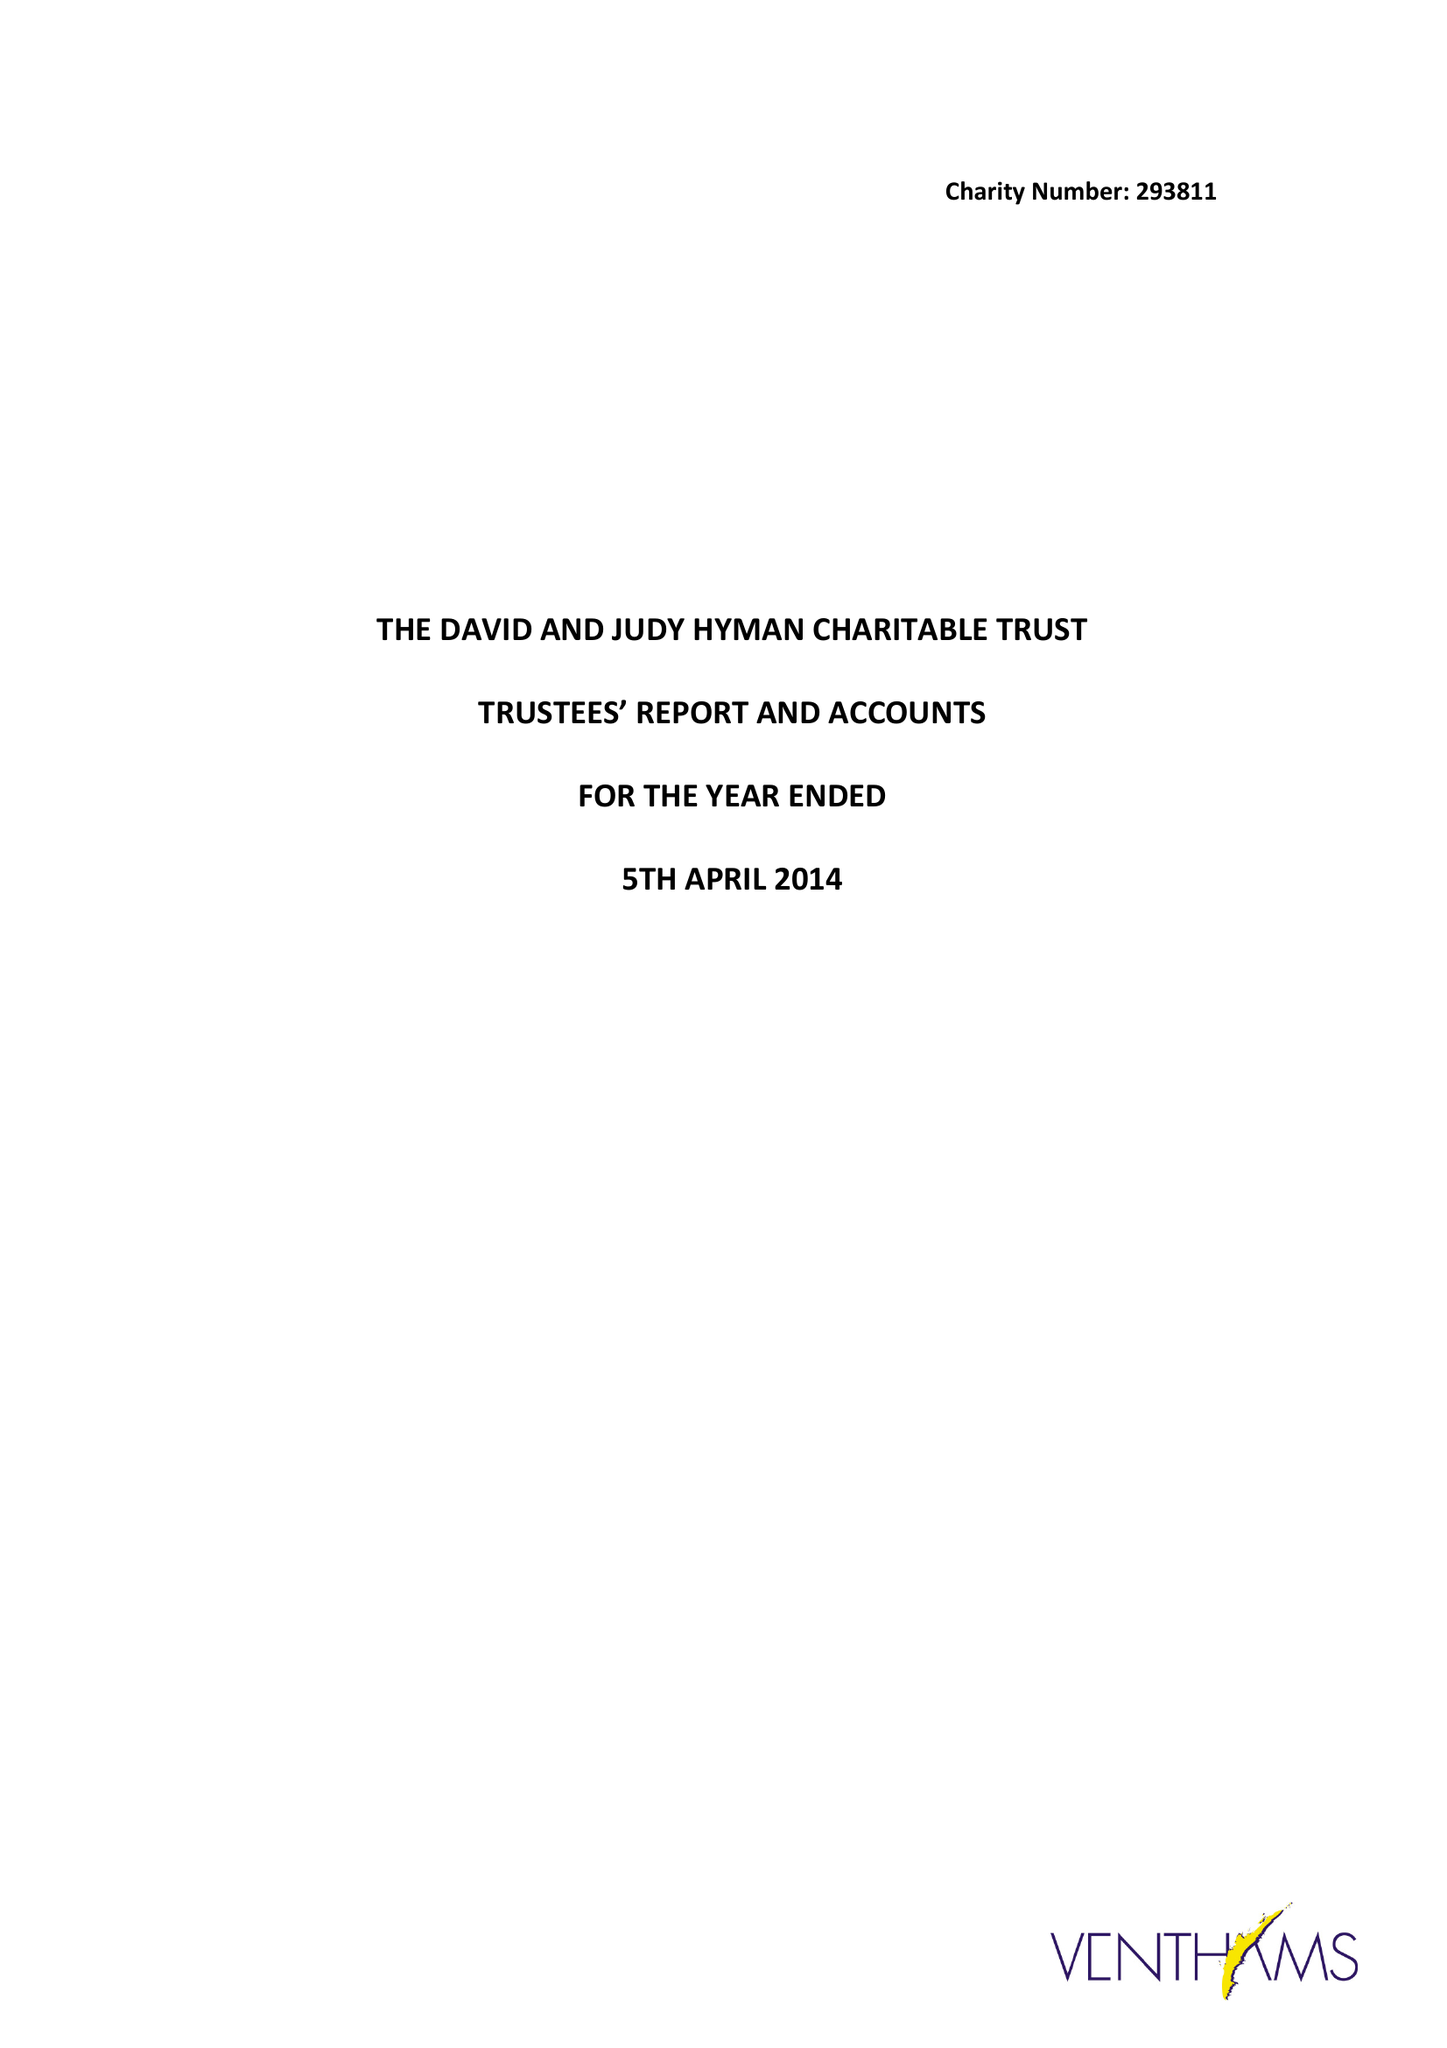What is the value for the charity_name?
Answer the question using a single word or phrase. The David and Judy Hyman Charitable Trust 